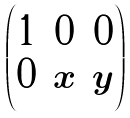Convert formula to latex. <formula><loc_0><loc_0><loc_500><loc_500>\begin{pmatrix} 1 & 0 & 0 \\ 0 & x & y \end{pmatrix}</formula> 